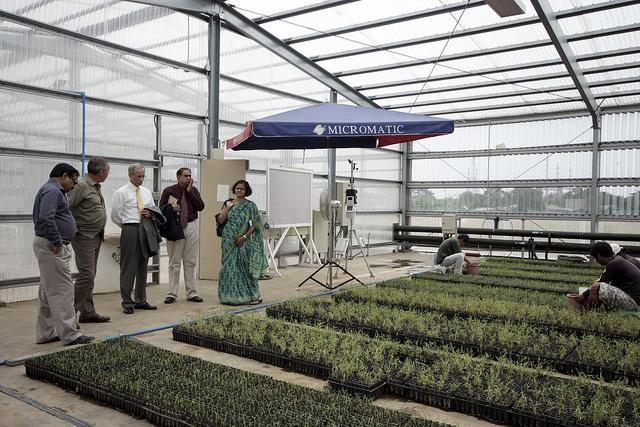What might the temperature be like where they are standing?

Choices:
A) dry
B) cold
C) moist
D) humid humid 